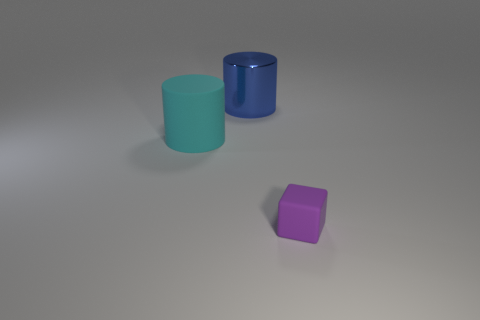Add 1 green balls. How many objects exist? 4 Subtract all big cyan things. Subtract all tiny cyan shiny objects. How many objects are left? 2 Add 1 big cyan cylinders. How many big cyan cylinders are left? 2 Add 1 big blue metallic things. How many big blue metallic things exist? 2 Subtract 0 brown spheres. How many objects are left? 3 Subtract all cubes. How many objects are left? 2 Subtract all brown cylinders. Subtract all purple spheres. How many cylinders are left? 2 